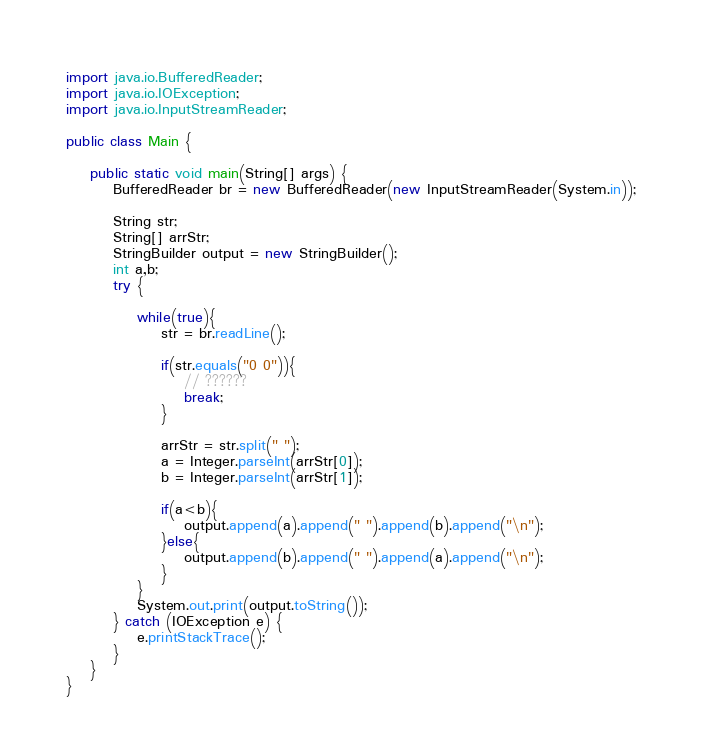Convert code to text. <code><loc_0><loc_0><loc_500><loc_500><_Java_>
import java.io.BufferedReader;
import java.io.IOException;
import java.io.InputStreamReader;

public class Main {

	public static void main(String[] args) {
		BufferedReader br = new BufferedReader(new InputStreamReader(System.in));

		String str;
		String[] arrStr;
		StringBuilder output = new StringBuilder();
		int a,b;
		try {

			while(true){
				str = br.readLine();

				if(str.equals("0 0")){
					// ??????
					break;
				}

				arrStr = str.split(" ");
				a = Integer.parseInt(arrStr[0]);
				b = Integer.parseInt(arrStr[1]);

				if(a<b){
					output.append(a).append(" ").append(b).append("\n");
				}else{
					output.append(b).append(" ").append(a).append("\n");
				}
			}
			System.out.print(output.toString());
		} catch (IOException e) {
			e.printStackTrace();
		}
	}
}</code> 